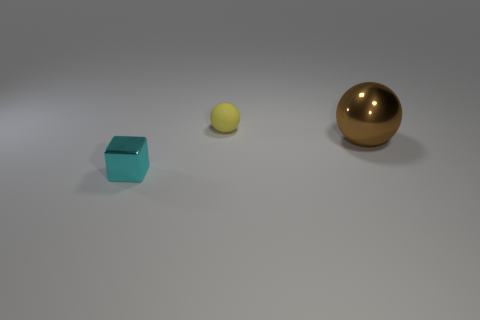Add 3 small balls. How many objects exist? 6 Subtract all spheres. How many objects are left? 1 Add 1 small yellow objects. How many small yellow objects are left? 2 Add 1 large brown metallic balls. How many large brown metallic balls exist? 2 Subtract 0 purple cylinders. How many objects are left? 3 Subtract all metallic cubes. Subtract all cyan shiny blocks. How many objects are left? 1 